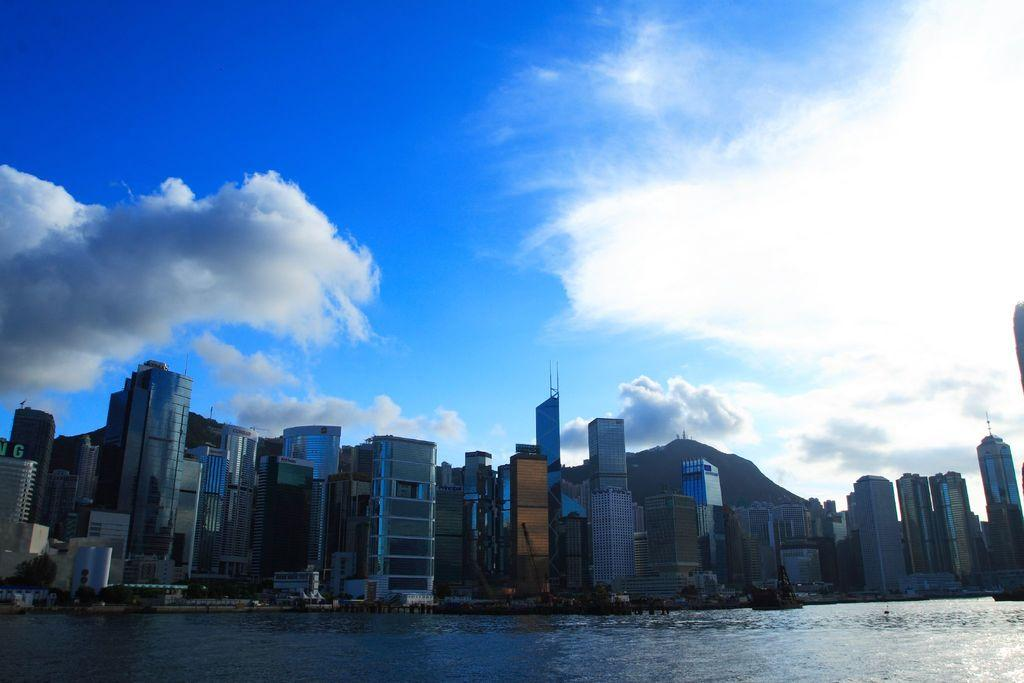What type of structures are present in the image? There are buildings and skyscrapers in the image. What can be seen at the bottom of the image? There is water visible at the bottom of the image. What is visible in the background of the image? The sky is visible in the background of the image. What can be observed in the sky in the background of the image? There are clouds in the sky in the background of the image. How many dogs are visible in the image? There are no dogs present in the image. What type of insurance policy is being discussed in the image? There is no discussion of insurance in the image. 